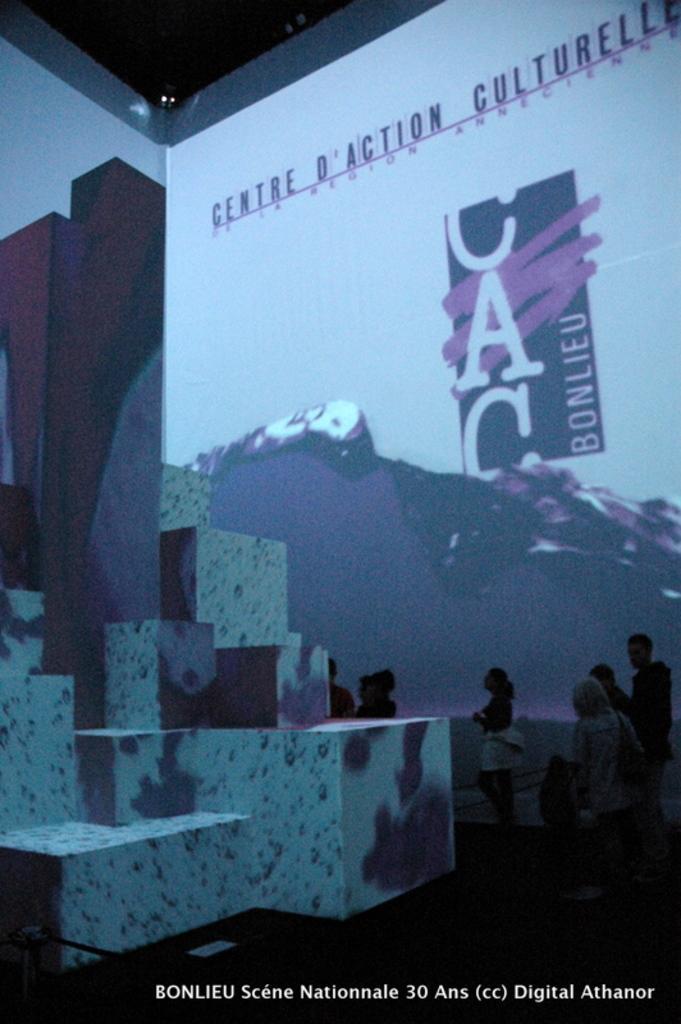Can you describe this image briefly? This image consists of few persons. In the front, it looks like a screen. At the bottom, there is a floor. At the top, there is a roof. On the left, it looks like a block. 